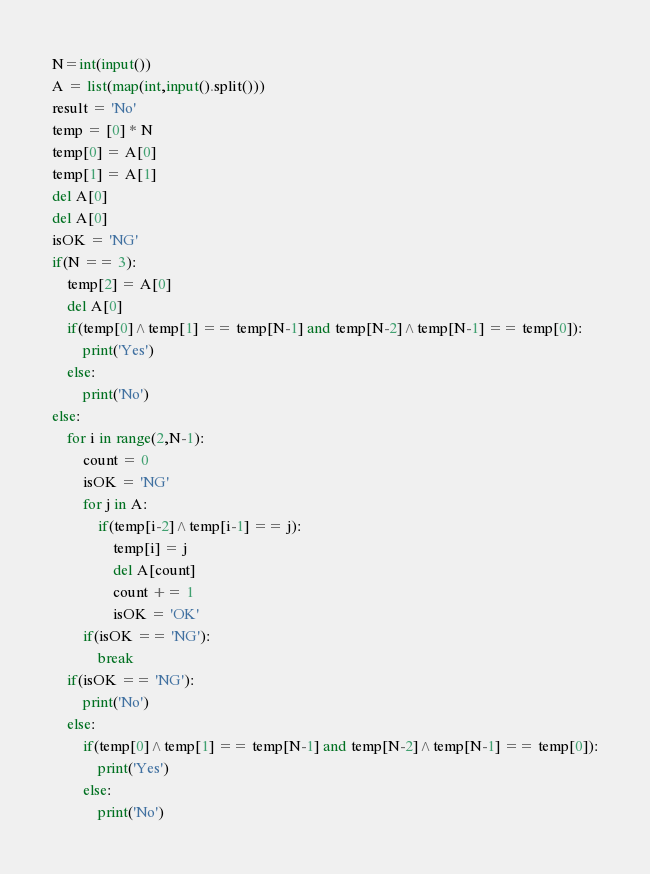<code> <loc_0><loc_0><loc_500><loc_500><_Python_>N=int(input())
A = list(map(int,input().split()))
result = 'No'
temp = [0] * N
temp[0] = A[0]
temp[1] = A[1]
del A[0]
del A[0]
isOK = 'NG'
if(N == 3):
    temp[2] = A[0]
    del A[0]
    if(temp[0]^temp[1] == temp[N-1] and temp[N-2]^temp[N-1] == temp[0]):
        print('Yes')
    else:
        print('No')
else:
    for i in range(2,N-1):
        count = 0
        isOK = 'NG'
        for j in A:
            if(temp[i-2]^temp[i-1] == j):
                temp[i] = j
                del A[count]
                count += 1
                isOK = 'OK'
        if(isOK == 'NG'):
            break
    if(isOK == 'NG'):
        print('No')
    else:
        if(temp[0]^temp[1] == temp[N-1] and temp[N-2]^temp[N-1] == temp[0]):
            print('Yes')
        else:
            print('No')</code> 